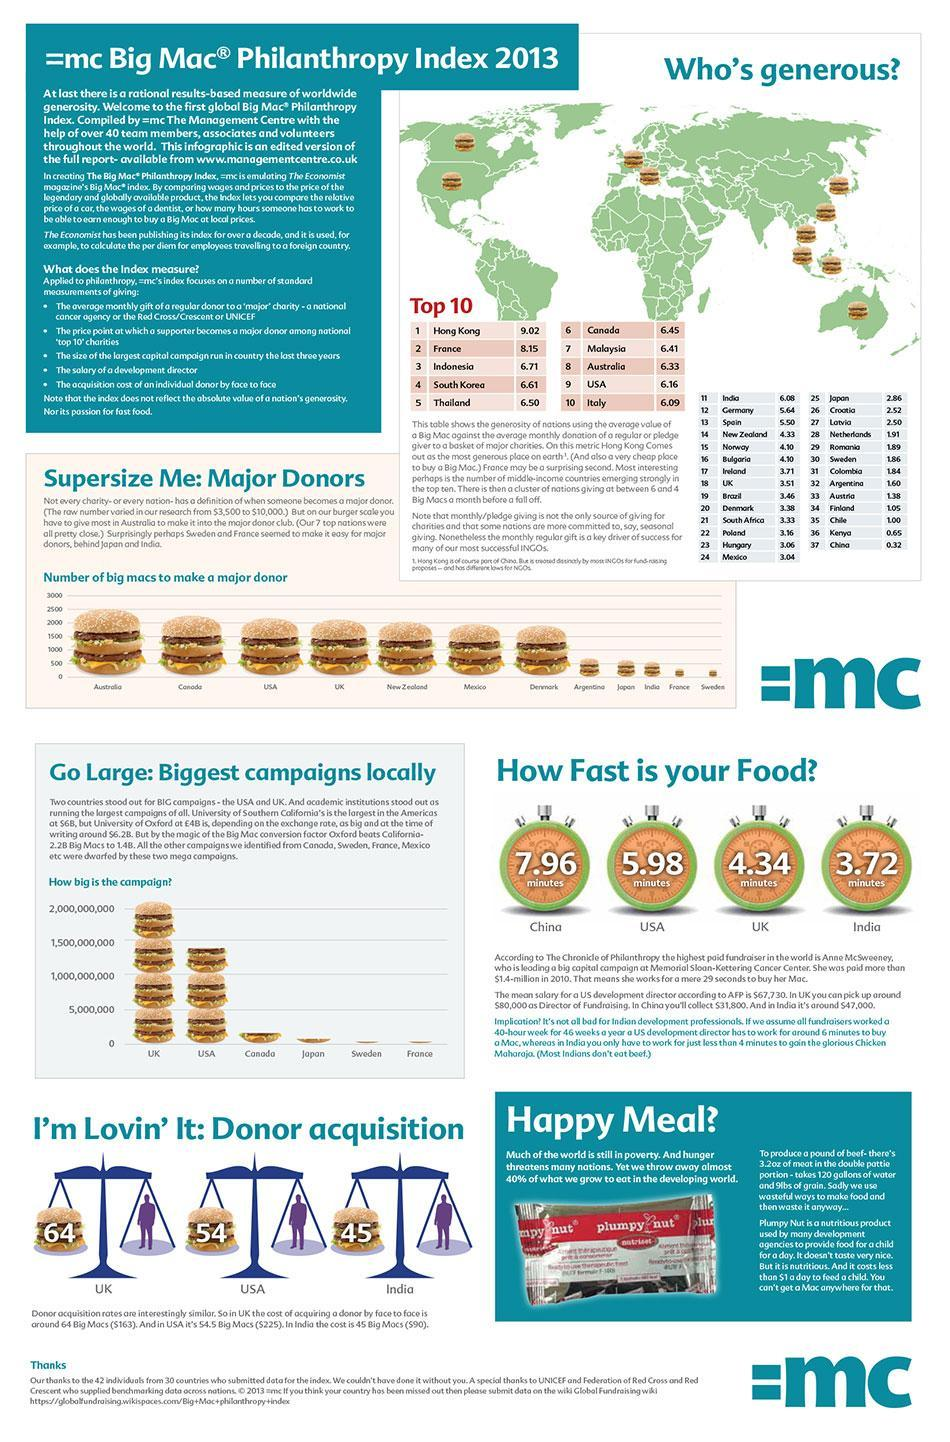What is the number of Big Macs needed to make a major donor, in Canada?
Answer the question with a short phrase. 2250 How many burger images are there on the world map? 10 What is the name of the Happy meal provided to the poor children? Plumpy nut Which two countries, need less than 2000 but more than 1000 Big Macs, to make a major donor? Mexico, Denmark In the generosity ranking, which nations have given less than one Big Mac? Kenya, China In the generosity ranking, how many nations have given between 6 and 5 Big Macs? 2 Who is the second most generous in the world? France Campaigns of which 3 countries, other than Japan, did not even reach 5 million? Canada, Sweden, France 